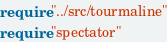Convert code to text. <code><loc_0><loc_0><loc_500><loc_500><_Crystal_>require "../src/tourmaline"
require "spectator"
</code> 